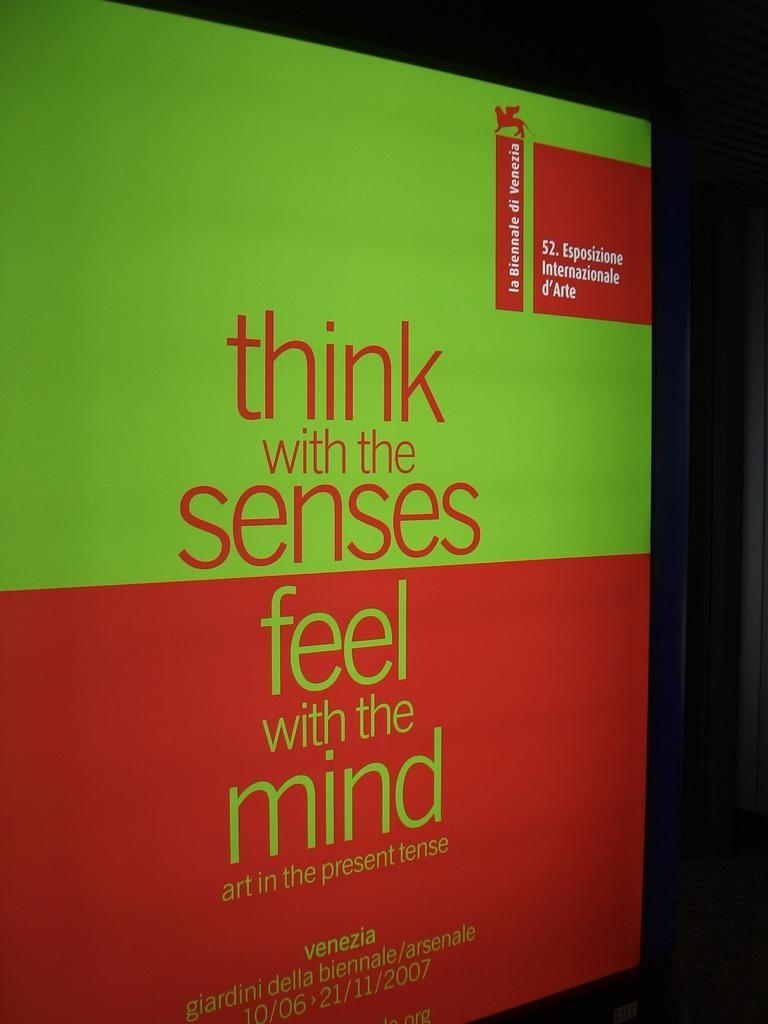<image>
Render a clear and concise summary of the photo. Book that says "Think with the senses" and "Feel with the mind". 